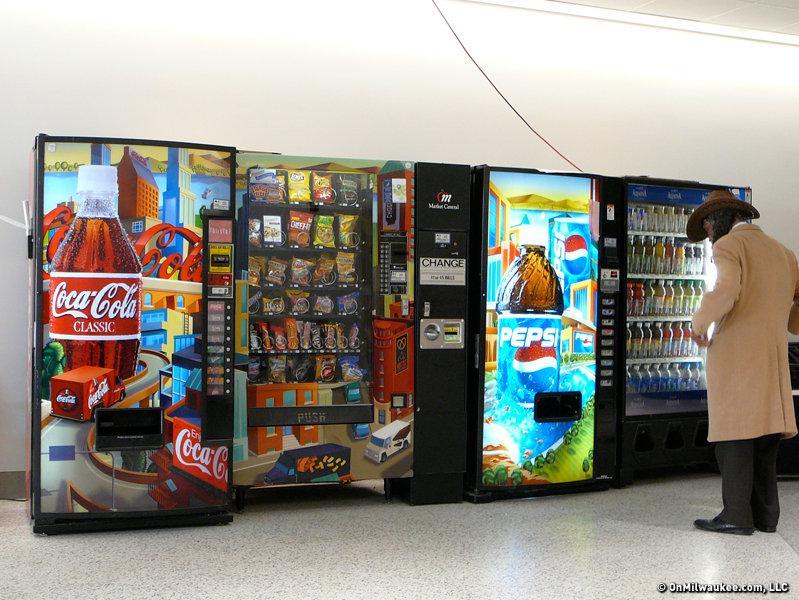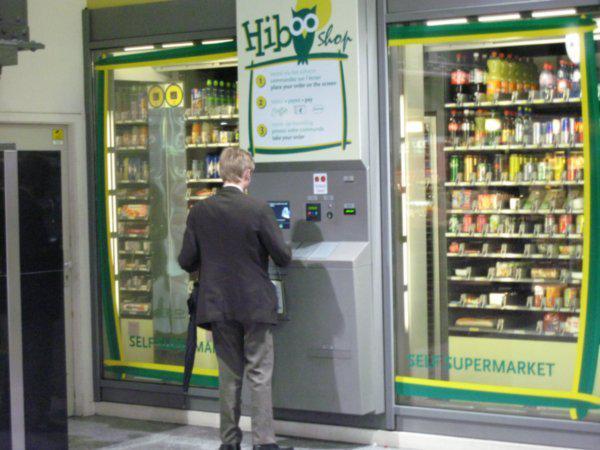The first image is the image on the left, the second image is the image on the right. Analyze the images presented: Is the assertion "In the left image, there are at least four different vending machines." valid? Answer yes or no. Yes. 